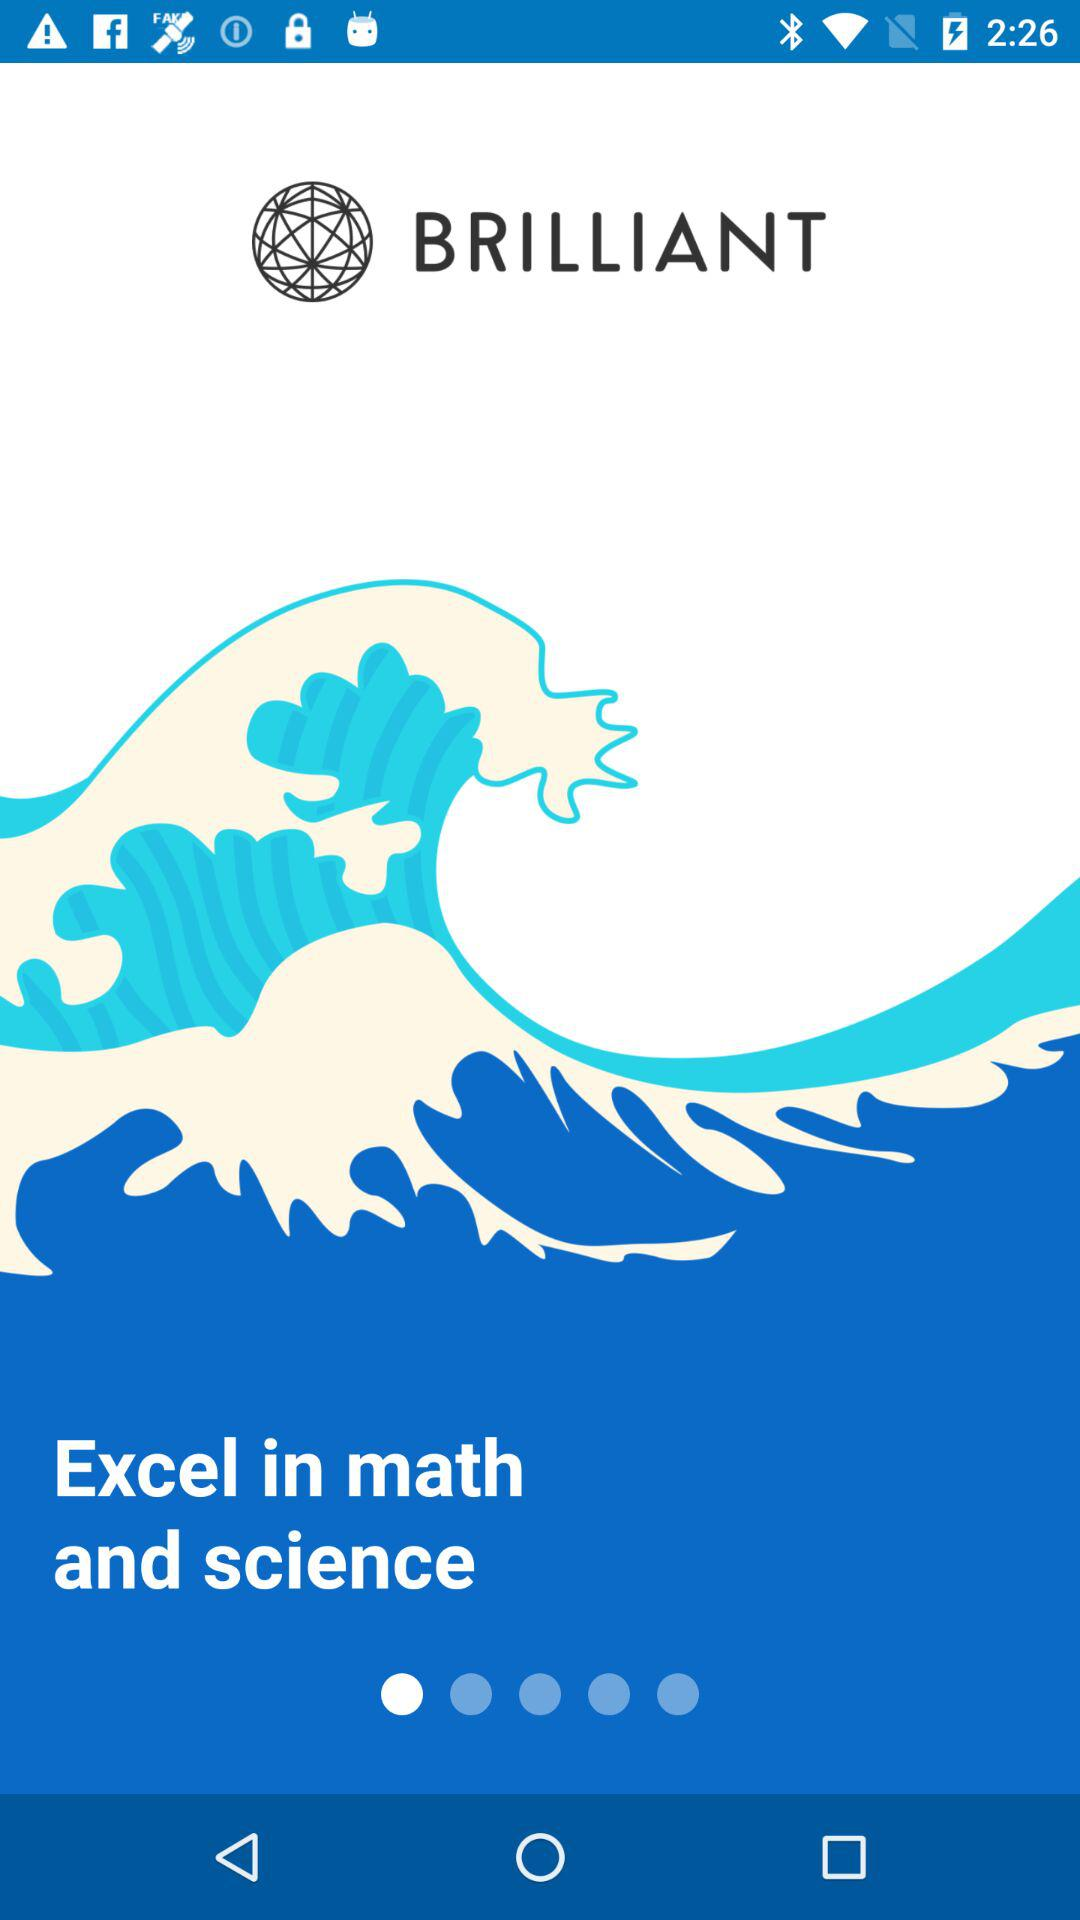Which two subjects are mentioned? The mentioned subjects are math and science. 